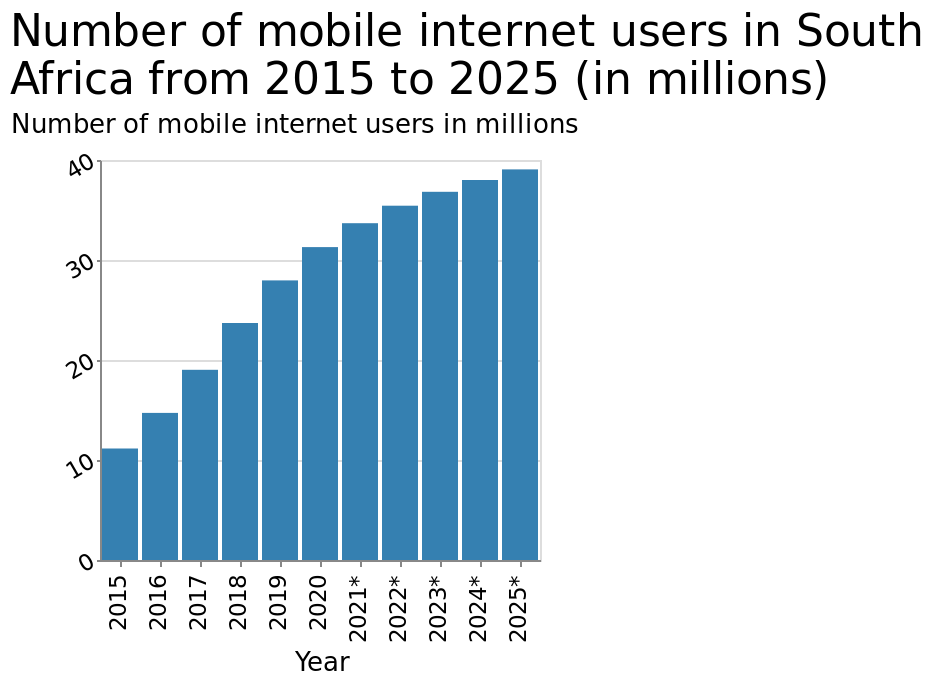<image>
In what unit is the number of mobile internet users measured on the bar graph? The number of mobile internet users is measured in millions on the bar graph. Describe the following image in detail This is a bar graph titled Number of mobile internet users in South Africa from 2015 to 2025 (in millions). The x-axis shows Year while the y-axis shows Number of mobile internet users in millions. 